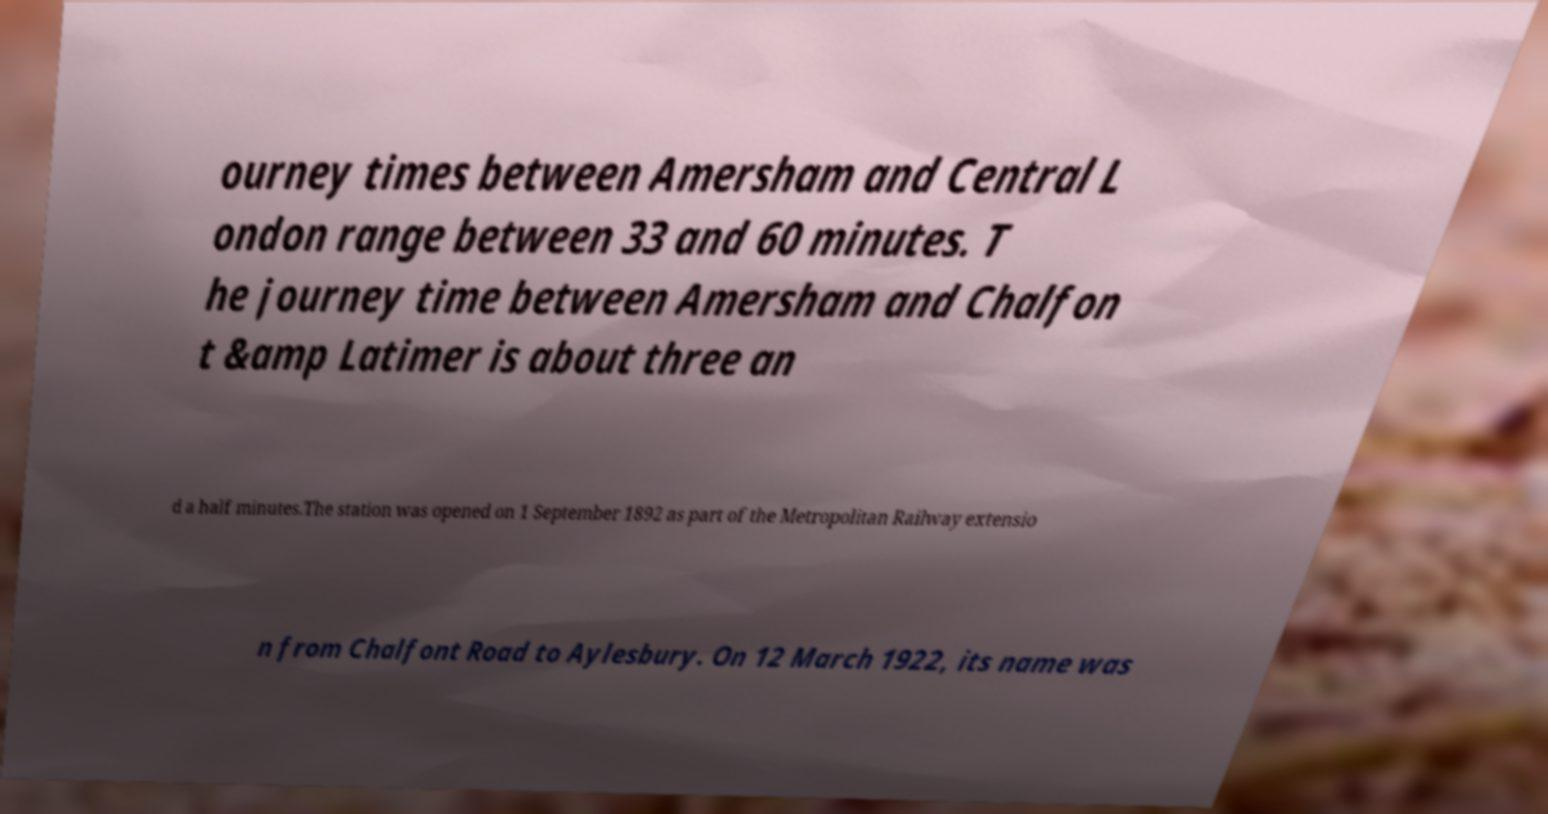There's text embedded in this image that I need extracted. Can you transcribe it verbatim? ourney times between Amersham and Central L ondon range between 33 and 60 minutes. T he journey time between Amersham and Chalfon t &amp Latimer is about three an d a half minutes.The station was opened on 1 September 1892 as part of the Metropolitan Railway extensio n from Chalfont Road to Aylesbury. On 12 March 1922, its name was 